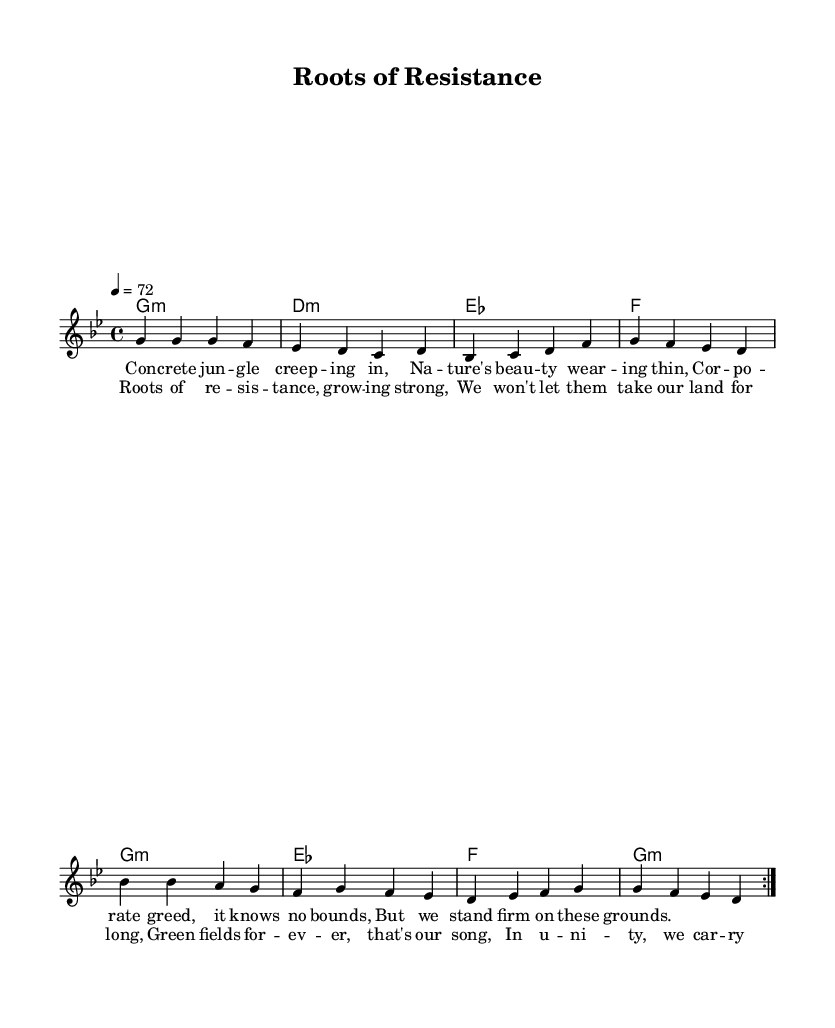What is the key signature of this music? The key signature is G minor, which has two flats (B♭ and E♭).
Answer: G minor What is the time signature of the sheet music? The time signature is indicated at the beginning as 4/4, meaning there are four beats in a measure and the quarter note gets one beat.
Answer: 4/4 What is the tempo marking for this piece? The tempo marking shows 4 = 72, indicating that there are 72 quarter notes per minute in this reggae piece.
Answer: 72 How many verses are in the song? The song structure is indicated by the repeat in the melody section, which suggests that there is one verse that is repeated, making it one complete verse.
Answer: 1 What defines this piece as a reggae song? This song features themes of resistance against corporate greed and environmental issues, which are common in reggae music, along with a rhythmic style similar to that genre.
Answer: Resistance theme What is the main message of the chorus? The chorus emphasizes unity and the determination to protect land and nature, encapsulating the collective spirit found in reggae protest songs.
Answer: Unity and protection What type of chords are primarily used in this piece? The chords in the harmonies section are primarily minor and major, which are typical in reggae music, with a focus on a minor key, enhancing the emotional depth of the protest theme.
Answer: Minor and major 